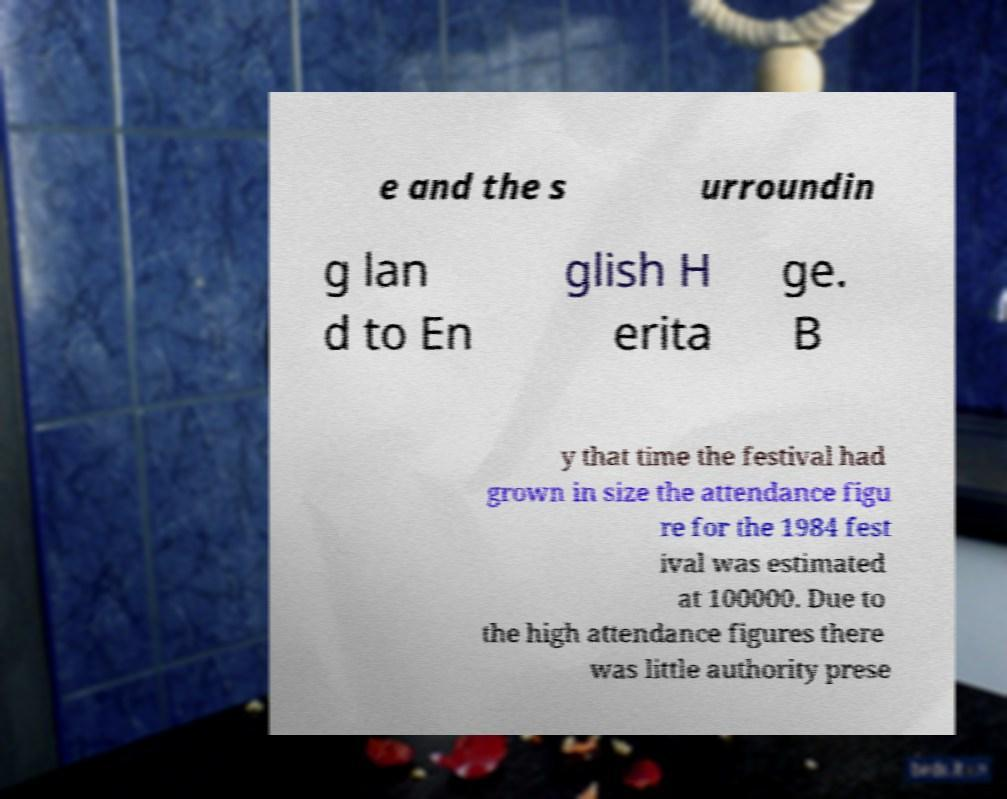Please read and relay the text visible in this image. What does it say? e and the s urroundin g lan d to En glish H erita ge. B y that time the festival had grown in size the attendance figu re for the 1984 fest ival was estimated at 100000. Due to the high attendance figures there was little authority prese 